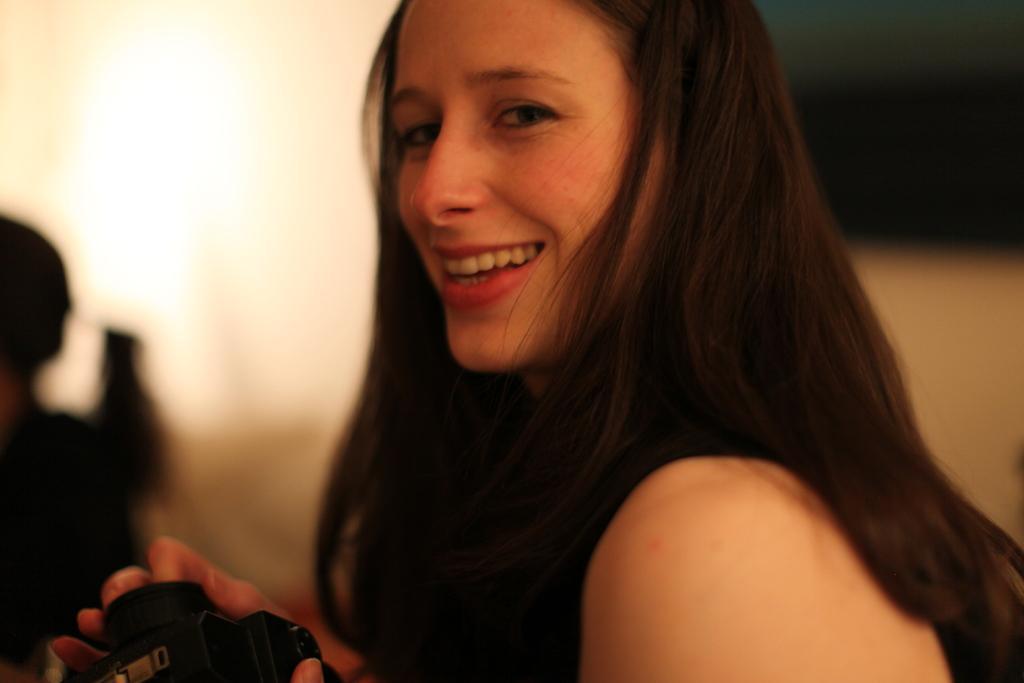Could you give a brief overview of what you see in this image? A woman is smiling and holding a camera. 